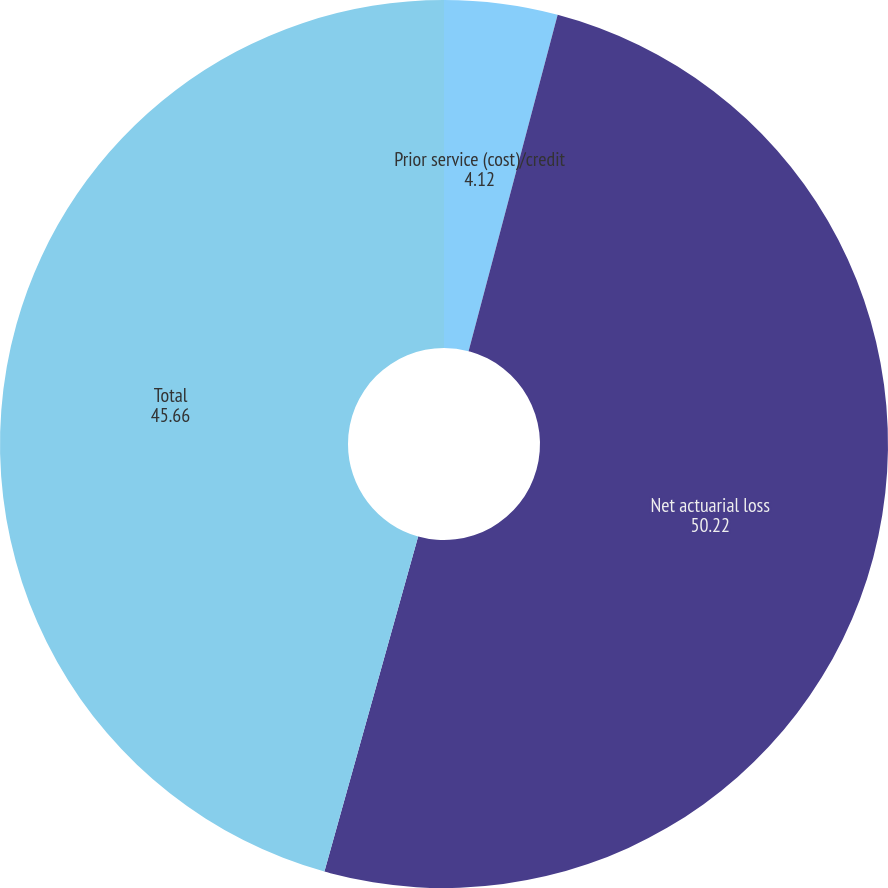Convert chart to OTSL. <chart><loc_0><loc_0><loc_500><loc_500><pie_chart><fcel>Prior service (cost)/credit<fcel>Net actuarial loss<fcel>Total<nl><fcel>4.12%<fcel>50.22%<fcel>45.66%<nl></chart> 